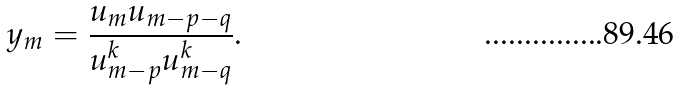<formula> <loc_0><loc_0><loc_500><loc_500>y _ { m } = \frac { u _ { m } u _ { m - p - q } } { u _ { m - p } ^ { k } u _ { m - q } ^ { k } } .</formula> 